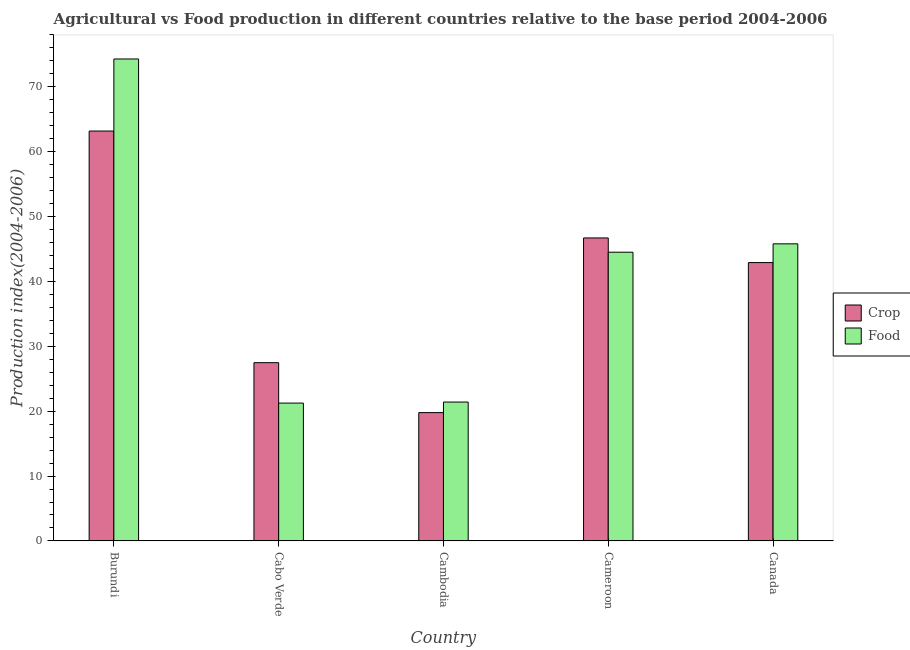How many different coloured bars are there?
Your answer should be very brief. 2. How many groups of bars are there?
Your response must be concise. 5. Are the number of bars per tick equal to the number of legend labels?
Offer a terse response. Yes. How many bars are there on the 4th tick from the left?
Offer a terse response. 2. How many bars are there on the 4th tick from the right?
Your answer should be compact. 2. What is the label of the 1st group of bars from the left?
Ensure brevity in your answer.  Burundi. What is the food production index in Canada?
Offer a very short reply. 45.8. Across all countries, what is the maximum crop production index?
Offer a very short reply. 63.19. Across all countries, what is the minimum food production index?
Offer a terse response. 21.25. In which country was the food production index maximum?
Keep it short and to the point. Burundi. In which country was the crop production index minimum?
Your response must be concise. Cambodia. What is the total crop production index in the graph?
Ensure brevity in your answer.  200.07. What is the difference between the crop production index in Cabo Verde and that in Cameroon?
Provide a succinct answer. -19.23. What is the difference between the crop production index in Cambodia and the food production index in Cabo Verde?
Offer a very short reply. -1.47. What is the average food production index per country?
Your response must be concise. 41.45. What is the difference between the crop production index and food production index in Cabo Verde?
Offer a terse response. 6.23. What is the ratio of the crop production index in Burundi to that in Cabo Verde?
Offer a very short reply. 2.3. Is the difference between the food production index in Burundi and Cabo Verde greater than the difference between the crop production index in Burundi and Cabo Verde?
Offer a very short reply. Yes. What is the difference between the highest and the second highest crop production index?
Keep it short and to the point. 16.48. What is the difference between the highest and the lowest food production index?
Provide a short and direct response. 53.05. In how many countries, is the crop production index greater than the average crop production index taken over all countries?
Keep it short and to the point. 3. Is the sum of the crop production index in Cambodia and Canada greater than the maximum food production index across all countries?
Offer a terse response. No. What does the 1st bar from the left in Cabo Verde represents?
Provide a short and direct response. Crop. What does the 1st bar from the right in Cambodia represents?
Give a very brief answer. Food. Are all the bars in the graph horizontal?
Your answer should be very brief. No. Does the graph contain grids?
Provide a short and direct response. No. Where does the legend appear in the graph?
Your answer should be very brief. Center right. How many legend labels are there?
Ensure brevity in your answer.  2. What is the title of the graph?
Provide a succinct answer. Agricultural vs Food production in different countries relative to the base period 2004-2006. What is the label or title of the Y-axis?
Your response must be concise. Production index(2004-2006). What is the Production index(2004-2006) of Crop in Burundi?
Provide a short and direct response. 63.19. What is the Production index(2004-2006) in Food in Burundi?
Keep it short and to the point. 74.3. What is the Production index(2004-2006) of Crop in Cabo Verde?
Ensure brevity in your answer.  27.48. What is the Production index(2004-2006) of Food in Cabo Verde?
Offer a very short reply. 21.25. What is the Production index(2004-2006) in Crop in Cambodia?
Offer a terse response. 19.78. What is the Production index(2004-2006) of Food in Cambodia?
Ensure brevity in your answer.  21.41. What is the Production index(2004-2006) in Crop in Cameroon?
Ensure brevity in your answer.  46.71. What is the Production index(2004-2006) of Food in Cameroon?
Offer a very short reply. 44.51. What is the Production index(2004-2006) of Crop in Canada?
Give a very brief answer. 42.91. What is the Production index(2004-2006) of Food in Canada?
Keep it short and to the point. 45.8. Across all countries, what is the maximum Production index(2004-2006) of Crop?
Keep it short and to the point. 63.19. Across all countries, what is the maximum Production index(2004-2006) in Food?
Your response must be concise. 74.3. Across all countries, what is the minimum Production index(2004-2006) of Crop?
Make the answer very short. 19.78. Across all countries, what is the minimum Production index(2004-2006) in Food?
Offer a terse response. 21.25. What is the total Production index(2004-2006) in Crop in the graph?
Offer a very short reply. 200.07. What is the total Production index(2004-2006) of Food in the graph?
Make the answer very short. 207.27. What is the difference between the Production index(2004-2006) in Crop in Burundi and that in Cabo Verde?
Keep it short and to the point. 35.71. What is the difference between the Production index(2004-2006) in Food in Burundi and that in Cabo Verde?
Your response must be concise. 53.05. What is the difference between the Production index(2004-2006) of Crop in Burundi and that in Cambodia?
Provide a succinct answer. 43.41. What is the difference between the Production index(2004-2006) of Food in Burundi and that in Cambodia?
Ensure brevity in your answer.  52.89. What is the difference between the Production index(2004-2006) in Crop in Burundi and that in Cameroon?
Your answer should be very brief. 16.48. What is the difference between the Production index(2004-2006) in Food in Burundi and that in Cameroon?
Provide a succinct answer. 29.79. What is the difference between the Production index(2004-2006) of Crop in Burundi and that in Canada?
Keep it short and to the point. 20.28. What is the difference between the Production index(2004-2006) of Crop in Cabo Verde and that in Cambodia?
Offer a very short reply. 7.7. What is the difference between the Production index(2004-2006) of Food in Cabo Verde and that in Cambodia?
Give a very brief answer. -0.16. What is the difference between the Production index(2004-2006) in Crop in Cabo Verde and that in Cameroon?
Your answer should be compact. -19.23. What is the difference between the Production index(2004-2006) of Food in Cabo Verde and that in Cameroon?
Offer a terse response. -23.26. What is the difference between the Production index(2004-2006) of Crop in Cabo Verde and that in Canada?
Your response must be concise. -15.43. What is the difference between the Production index(2004-2006) of Food in Cabo Verde and that in Canada?
Your response must be concise. -24.55. What is the difference between the Production index(2004-2006) of Crop in Cambodia and that in Cameroon?
Your response must be concise. -26.93. What is the difference between the Production index(2004-2006) in Food in Cambodia and that in Cameroon?
Offer a very short reply. -23.1. What is the difference between the Production index(2004-2006) of Crop in Cambodia and that in Canada?
Keep it short and to the point. -23.13. What is the difference between the Production index(2004-2006) of Food in Cambodia and that in Canada?
Provide a short and direct response. -24.39. What is the difference between the Production index(2004-2006) of Crop in Cameroon and that in Canada?
Provide a short and direct response. 3.8. What is the difference between the Production index(2004-2006) of Food in Cameroon and that in Canada?
Provide a short and direct response. -1.29. What is the difference between the Production index(2004-2006) in Crop in Burundi and the Production index(2004-2006) in Food in Cabo Verde?
Your answer should be compact. 41.94. What is the difference between the Production index(2004-2006) of Crop in Burundi and the Production index(2004-2006) of Food in Cambodia?
Your answer should be compact. 41.78. What is the difference between the Production index(2004-2006) of Crop in Burundi and the Production index(2004-2006) of Food in Cameroon?
Keep it short and to the point. 18.68. What is the difference between the Production index(2004-2006) in Crop in Burundi and the Production index(2004-2006) in Food in Canada?
Offer a terse response. 17.39. What is the difference between the Production index(2004-2006) in Crop in Cabo Verde and the Production index(2004-2006) in Food in Cambodia?
Offer a very short reply. 6.07. What is the difference between the Production index(2004-2006) in Crop in Cabo Verde and the Production index(2004-2006) in Food in Cameroon?
Offer a very short reply. -17.03. What is the difference between the Production index(2004-2006) in Crop in Cabo Verde and the Production index(2004-2006) in Food in Canada?
Your answer should be very brief. -18.32. What is the difference between the Production index(2004-2006) in Crop in Cambodia and the Production index(2004-2006) in Food in Cameroon?
Offer a very short reply. -24.73. What is the difference between the Production index(2004-2006) in Crop in Cambodia and the Production index(2004-2006) in Food in Canada?
Offer a terse response. -26.02. What is the difference between the Production index(2004-2006) in Crop in Cameroon and the Production index(2004-2006) in Food in Canada?
Offer a very short reply. 0.91. What is the average Production index(2004-2006) in Crop per country?
Offer a terse response. 40.01. What is the average Production index(2004-2006) of Food per country?
Offer a very short reply. 41.45. What is the difference between the Production index(2004-2006) of Crop and Production index(2004-2006) of Food in Burundi?
Your answer should be compact. -11.11. What is the difference between the Production index(2004-2006) in Crop and Production index(2004-2006) in Food in Cabo Verde?
Provide a succinct answer. 6.23. What is the difference between the Production index(2004-2006) of Crop and Production index(2004-2006) of Food in Cambodia?
Your response must be concise. -1.63. What is the difference between the Production index(2004-2006) of Crop and Production index(2004-2006) of Food in Cameroon?
Provide a succinct answer. 2.2. What is the difference between the Production index(2004-2006) of Crop and Production index(2004-2006) of Food in Canada?
Your answer should be compact. -2.89. What is the ratio of the Production index(2004-2006) in Crop in Burundi to that in Cabo Verde?
Provide a short and direct response. 2.3. What is the ratio of the Production index(2004-2006) in Food in Burundi to that in Cabo Verde?
Your response must be concise. 3.5. What is the ratio of the Production index(2004-2006) of Crop in Burundi to that in Cambodia?
Your answer should be compact. 3.19. What is the ratio of the Production index(2004-2006) of Food in Burundi to that in Cambodia?
Make the answer very short. 3.47. What is the ratio of the Production index(2004-2006) in Crop in Burundi to that in Cameroon?
Keep it short and to the point. 1.35. What is the ratio of the Production index(2004-2006) of Food in Burundi to that in Cameroon?
Offer a terse response. 1.67. What is the ratio of the Production index(2004-2006) of Crop in Burundi to that in Canada?
Your answer should be very brief. 1.47. What is the ratio of the Production index(2004-2006) of Food in Burundi to that in Canada?
Make the answer very short. 1.62. What is the ratio of the Production index(2004-2006) of Crop in Cabo Verde to that in Cambodia?
Offer a terse response. 1.39. What is the ratio of the Production index(2004-2006) of Crop in Cabo Verde to that in Cameroon?
Provide a succinct answer. 0.59. What is the ratio of the Production index(2004-2006) of Food in Cabo Verde to that in Cameroon?
Provide a short and direct response. 0.48. What is the ratio of the Production index(2004-2006) in Crop in Cabo Verde to that in Canada?
Offer a very short reply. 0.64. What is the ratio of the Production index(2004-2006) in Food in Cabo Verde to that in Canada?
Make the answer very short. 0.46. What is the ratio of the Production index(2004-2006) in Crop in Cambodia to that in Cameroon?
Give a very brief answer. 0.42. What is the ratio of the Production index(2004-2006) in Food in Cambodia to that in Cameroon?
Provide a succinct answer. 0.48. What is the ratio of the Production index(2004-2006) in Crop in Cambodia to that in Canada?
Provide a succinct answer. 0.46. What is the ratio of the Production index(2004-2006) in Food in Cambodia to that in Canada?
Your answer should be compact. 0.47. What is the ratio of the Production index(2004-2006) of Crop in Cameroon to that in Canada?
Your answer should be compact. 1.09. What is the ratio of the Production index(2004-2006) in Food in Cameroon to that in Canada?
Provide a succinct answer. 0.97. What is the difference between the highest and the second highest Production index(2004-2006) in Crop?
Provide a succinct answer. 16.48. What is the difference between the highest and the lowest Production index(2004-2006) in Crop?
Provide a succinct answer. 43.41. What is the difference between the highest and the lowest Production index(2004-2006) in Food?
Keep it short and to the point. 53.05. 